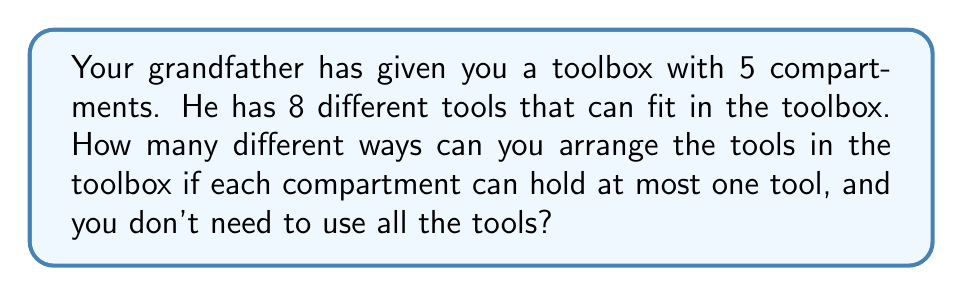What is the answer to this math problem? Let's approach this step-by-step:

1) First, we need to recognize that this is a combination problem with two key factors:
   - We're selecting tools from 8 options
   - We're placing them into 5 compartments

2) We can use the multiplication principle here. For each compartment, we have two choices:
   - Leave it empty
   - Put a tool in it

3) If we decide to put a tool in a compartment, we need to choose which tool. The number of available tools decreases as we fill compartments.

4) Let's break it down for each compartment:
   - 1st compartment: 9 choices (8 tools or leave empty)
   - 2nd compartment: 8 choices (7 remaining tools or leave empty)
   - 3rd compartment: 7 choices (6 remaining tools or leave empty)
   - 4th compartment: 6 choices (5 remaining tools or leave empty)
   - 5th compartment: 5 choices (4 remaining tools or leave empty)

5) By the multiplication principle, the total number of ways to arrange the tools is:

   $$ 9 \times 8 \times 7 \times 6 \times 5 = 15,120 $$

This calculation includes all possible arrangements, including leaving some or all compartments empty.
Answer: 15,120 